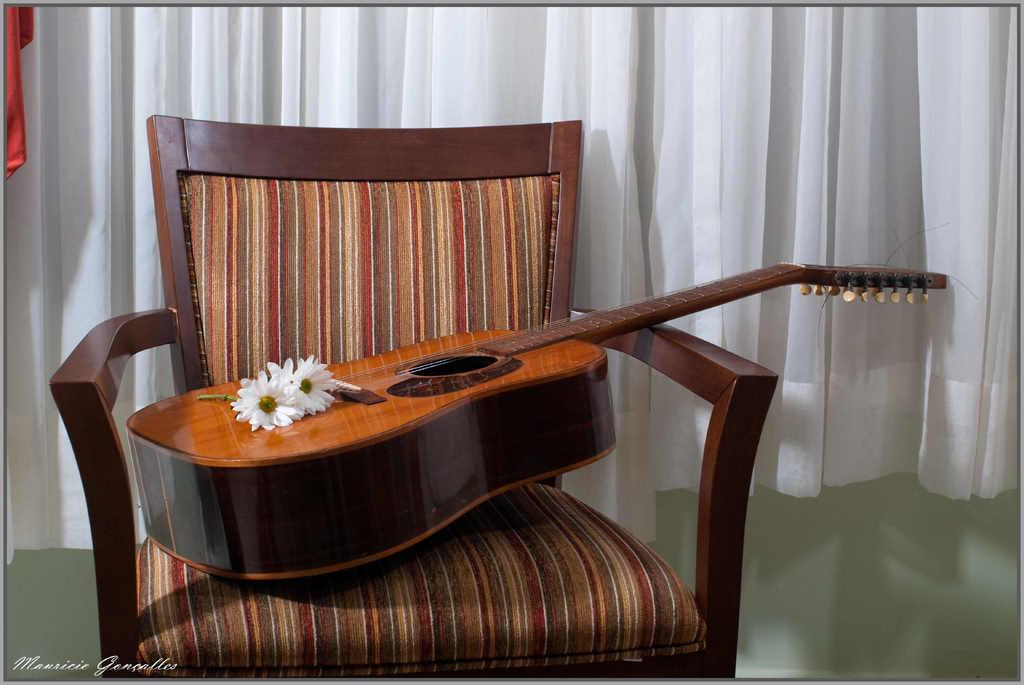What musical instrument is present in the picture? There is a guitar in the picture. What type of decoration can be seen on a chair in the picture? There are flowers on a chair in the picture. What type of window covering is present in the picture? There is a curtain in the picture. What type of payment is required for the pleasure of playing the guitar in the image? There is no indication of payment or pleasure associated with the guitar in the image; it is simply a musical instrument. What type of treatment is being administered to the flowers on the chair in the image? There is no treatment being administered to the flowers on the chair in the image; they are simply decorations. 